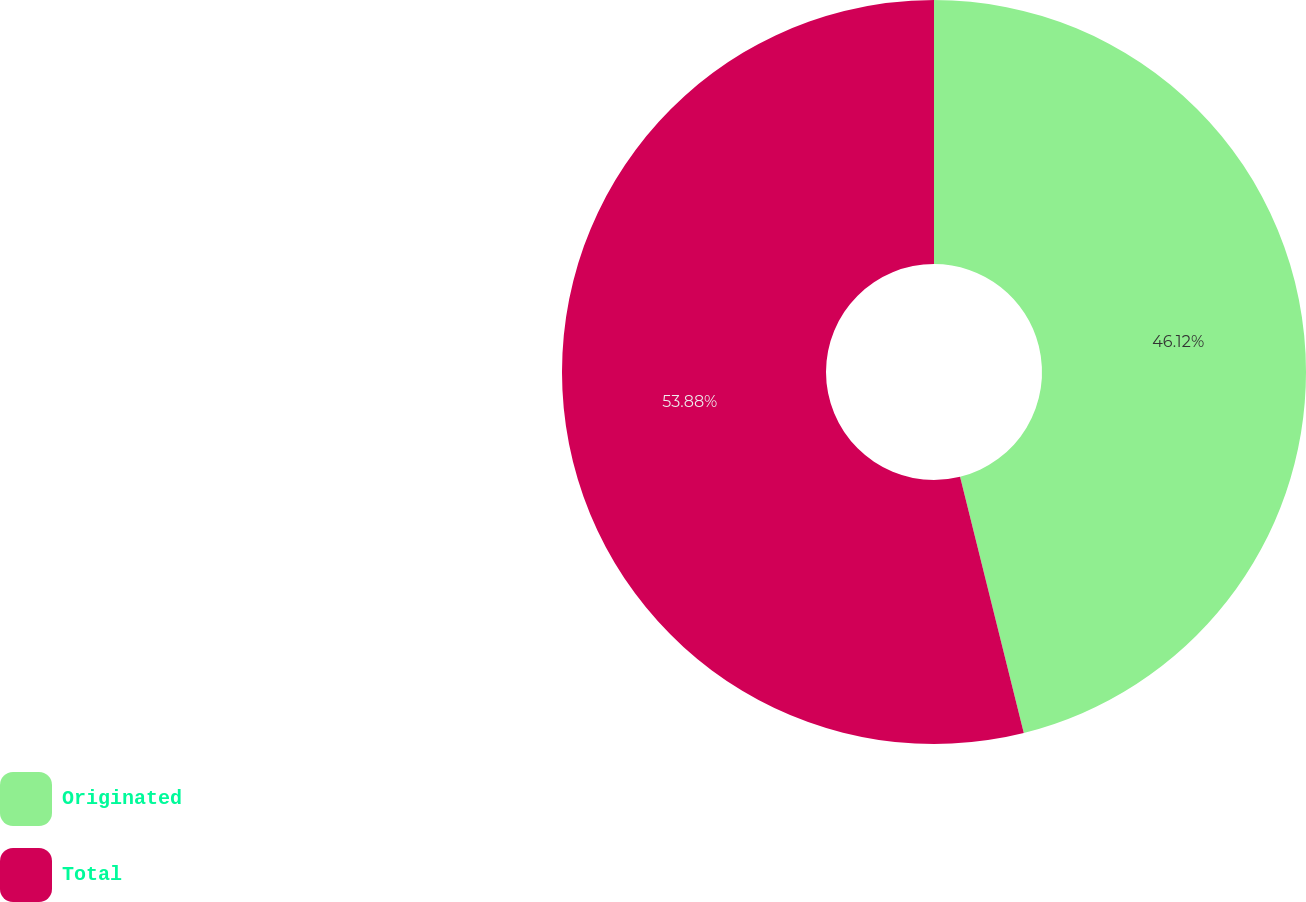Convert chart. <chart><loc_0><loc_0><loc_500><loc_500><pie_chart><fcel>Originated<fcel>Total<nl><fcel>46.12%<fcel>53.88%<nl></chart> 